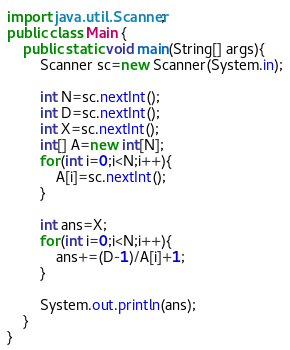<code> <loc_0><loc_0><loc_500><loc_500><_Java_>import java.util.Scanner;
public class Main {
    public static void main(String[] args){
        Scanner sc=new Scanner(System.in);
        
        int N=sc.nextInt();
        int D=sc.nextInt();
        int X=sc.nextInt();
        int[] A=new int[N];
        for(int i=0;i<N;i++){
            A[i]=sc.nextInt();
        }
        
        int ans=X;
        for(int i=0;i<N;i++){
            ans+=(D-1)/A[i]+1;
        }
        
        System.out.println(ans);
    }
}</code> 